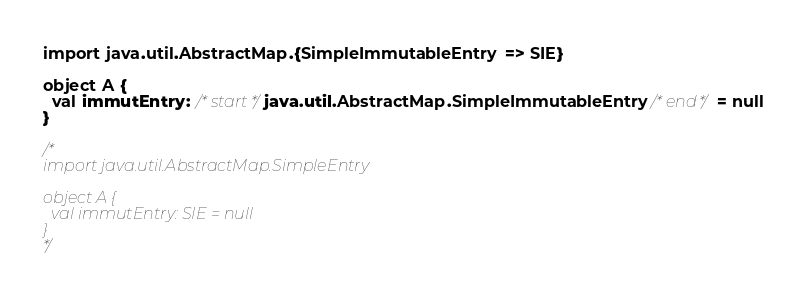Convert code to text. <code><loc_0><loc_0><loc_500><loc_500><_Scala_>import java.util.AbstractMap.{SimpleImmutableEntry => SIE}

object A {
  val immutEntry: /*start*/java.util.AbstractMap.SimpleImmutableEntry/*end*/ = null
}

/*
import java.util.AbstractMap.SimpleEntry

object A {
  val immutEntry: SIE = null
}
*/</code> 